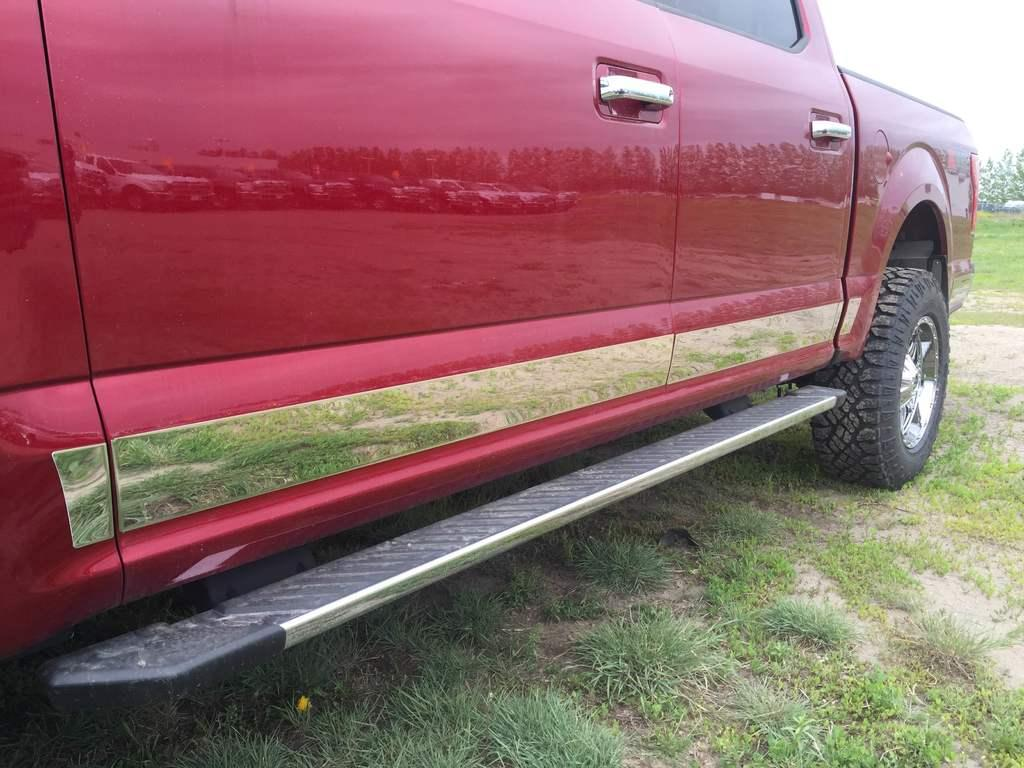What is the main subject of the image? There is a car in the image. What can be seen on the ground in the image? There is grass on the ground in the image. How many hens are sitting on the car in the image? There are no hens present in the image; it features a car and grass on the ground. What type of flame can be seen coming from the car's exhaust in the image? There is no flame visible in the image; it only shows a car and grass on the ground. 